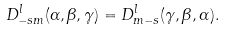Convert formula to latex. <formula><loc_0><loc_0><loc_500><loc_500>D _ { - s m } ^ { l } ( \alpha , \beta , \gamma ) = D _ { m - s } ^ { l } ( \gamma , \beta , \alpha ) .</formula> 